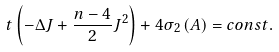Convert formula to latex. <formula><loc_0><loc_0><loc_500><loc_500>t \left ( - \Delta J + \frac { n - 4 } { 2 } J ^ { 2 } \right ) + 4 \sigma _ { 2 } \left ( A \right ) = c o n s t .</formula> 